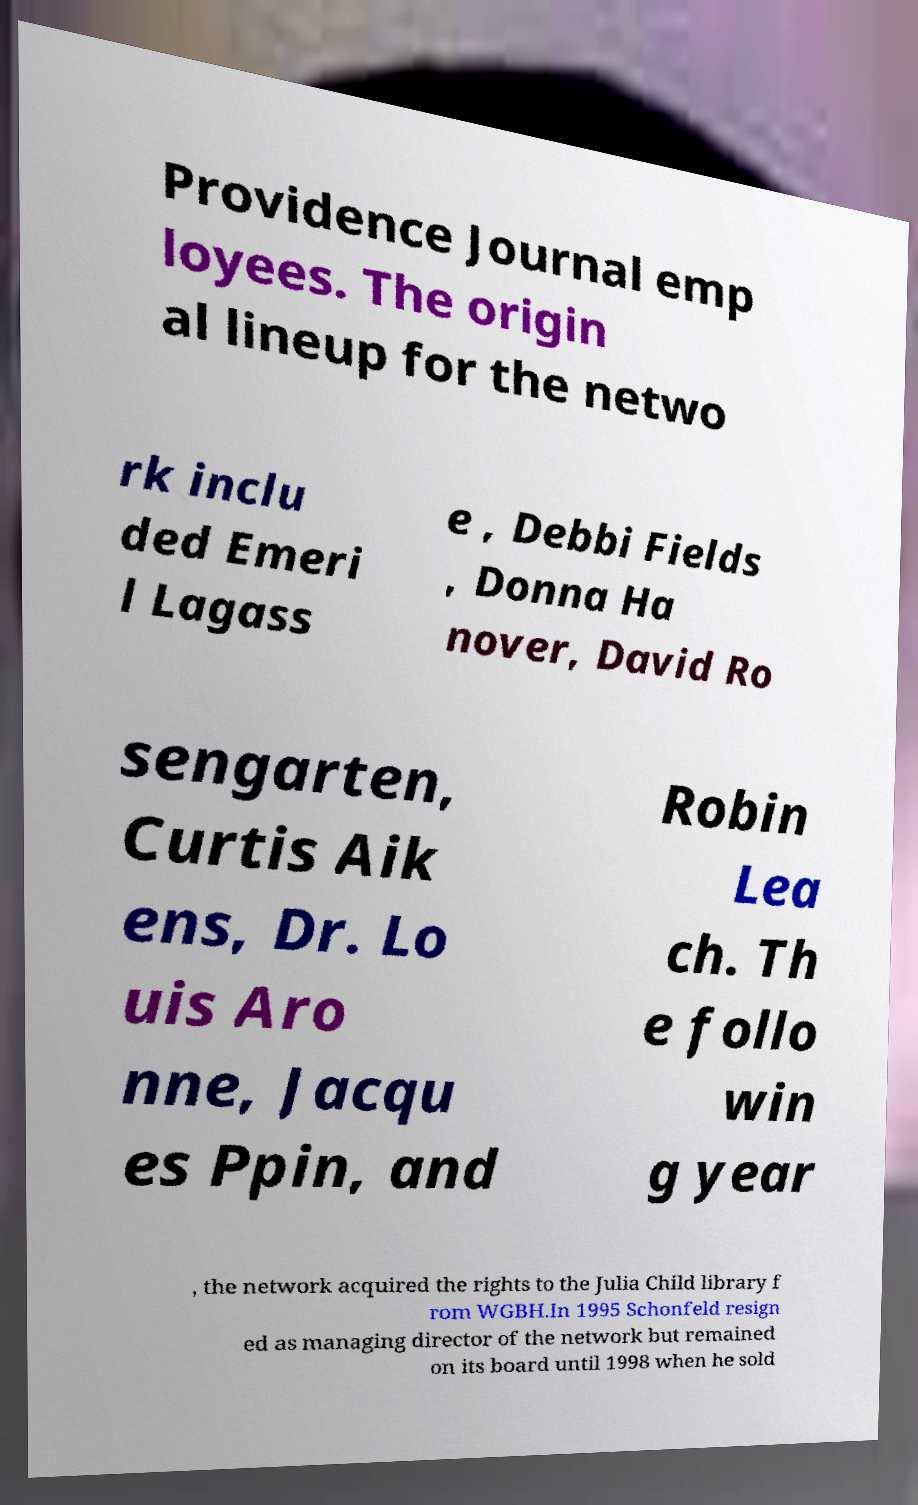For documentation purposes, I need the text within this image transcribed. Could you provide that? Providence Journal emp loyees. The origin al lineup for the netwo rk inclu ded Emeri l Lagass e , Debbi Fields , Donna Ha nover, David Ro sengarten, Curtis Aik ens, Dr. Lo uis Aro nne, Jacqu es Ppin, and Robin Lea ch. Th e follo win g year , the network acquired the rights to the Julia Child library f rom WGBH.In 1995 Schonfeld resign ed as managing director of the network but remained on its board until 1998 when he sold 